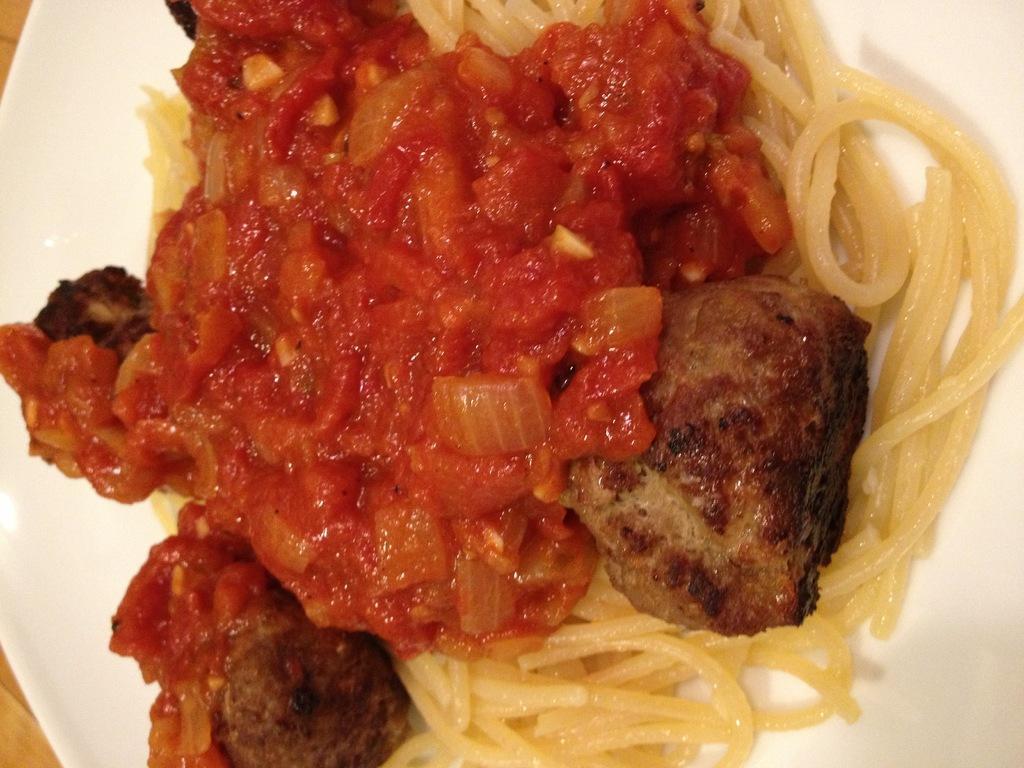Please provide a concise description of this image. In this picture we can see a table. On the table we can see a plate which contains food. 